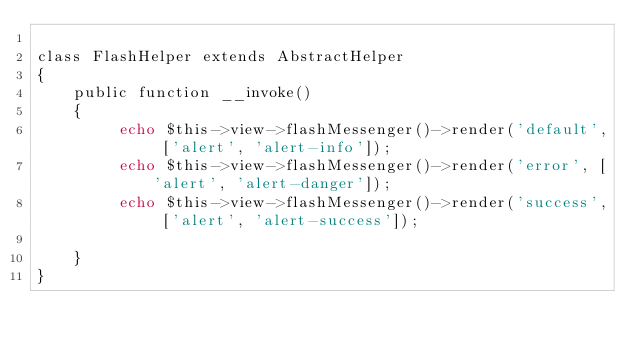Convert code to text. <code><loc_0><loc_0><loc_500><loc_500><_PHP_>
class FlashHelper extends AbstractHelper
{
	public function __invoke()
	{
		 echo $this->view->flashMessenger()->render('default', ['alert', 'alert-info']);
         echo $this->view->flashMessenger()->render('error', ['alert', 'alert-danger']);
         echo $this->view->flashMessenger()->render('success', ['alert', 'alert-success']);
       
	}
}</code> 